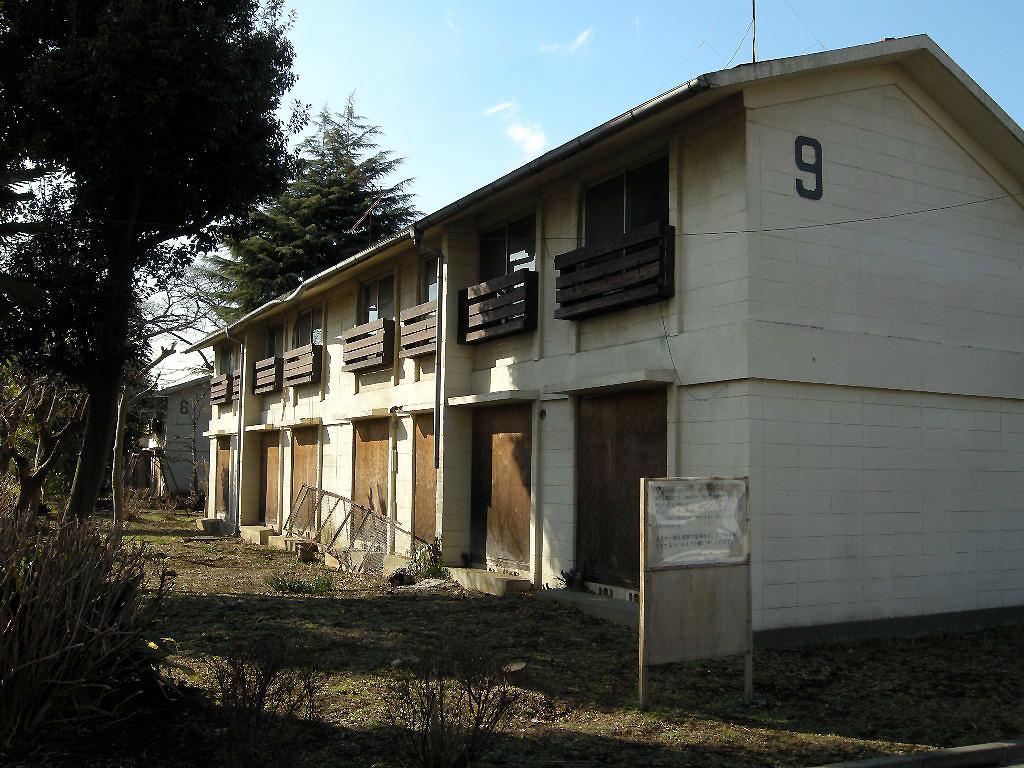How would you summarize this image in a sentence or two? In the image there is a building on the left side with trees in front of it on the right side and a board in the middle and above its sky with clouds. 